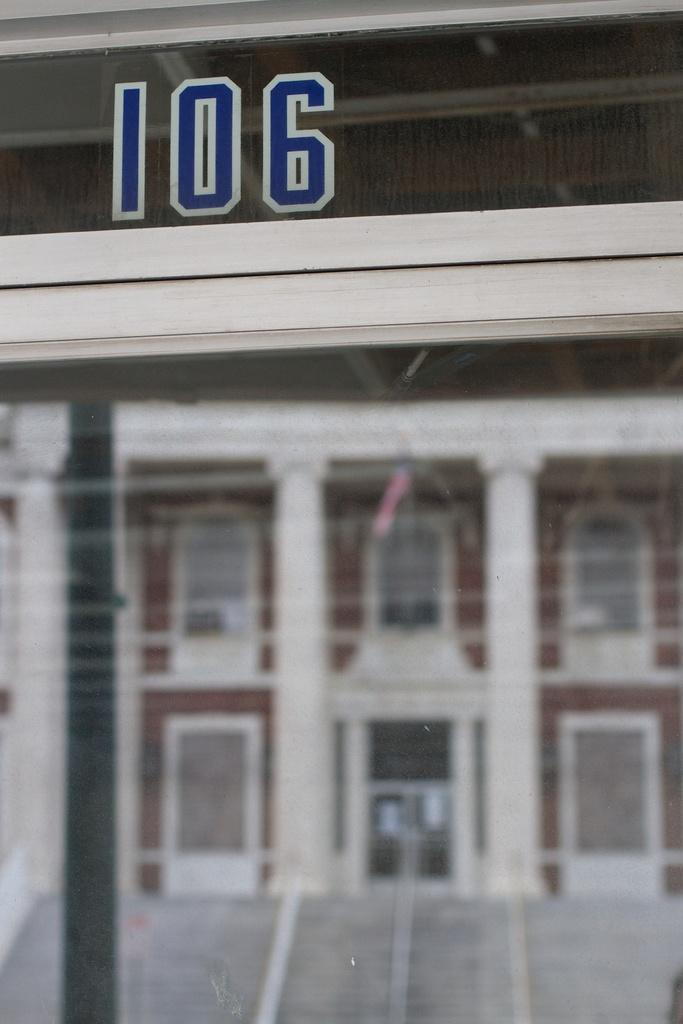<image>
Relay a brief, clear account of the picture shown. Store front which has the number 106 on it. 